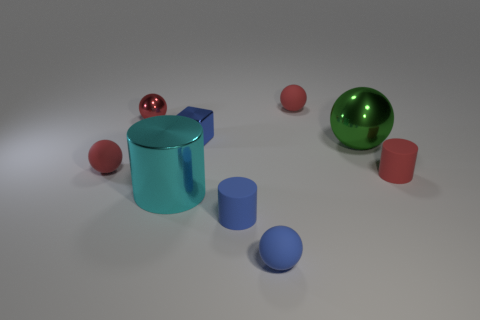Subtract all yellow cubes. How many red spheres are left? 3 Subtract 2 spheres. How many spheres are left? 3 Subtract all cyan metal cylinders. How many cylinders are left? 2 Add 1 cyan metal cylinders. How many objects exist? 10 Subtract all green spheres. How many spheres are left? 4 Subtract all green balls. Subtract all brown blocks. How many balls are left? 4 Subtract 1 blue blocks. How many objects are left? 8 Subtract all blocks. How many objects are left? 8 Subtract all red metal spheres. Subtract all rubber cylinders. How many objects are left? 6 Add 3 big green shiny balls. How many big green shiny balls are left? 4 